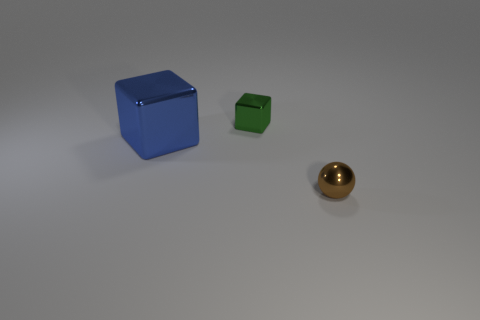There is a thing that is the same size as the green cube; what material is it?
Ensure brevity in your answer.  Metal. How many other objects are the same material as the green cube?
Your response must be concise. 2. What shape is the tiny thing that is to the left of the small shiny object in front of the small metal cube?
Your answer should be compact. Cube. How many other things are there of the same color as the big metallic block?
Ensure brevity in your answer.  0. Are the tiny object that is behind the small ball and the brown sphere to the right of the green metallic block made of the same material?
Keep it short and to the point. Yes. There is a shiny block that is in front of the green object; how big is it?
Provide a succinct answer. Large. Are there any other things that are the same size as the blue shiny cube?
Offer a very short reply. No. What shape is the tiny thing that is behind the blue shiny object?
Offer a very short reply. Cube. What number of brown metal objects have the same shape as the blue object?
Provide a succinct answer. 0. Are there an equal number of small blocks that are in front of the small ball and tiny green metal objects that are behind the green metal block?
Provide a short and direct response. Yes. 